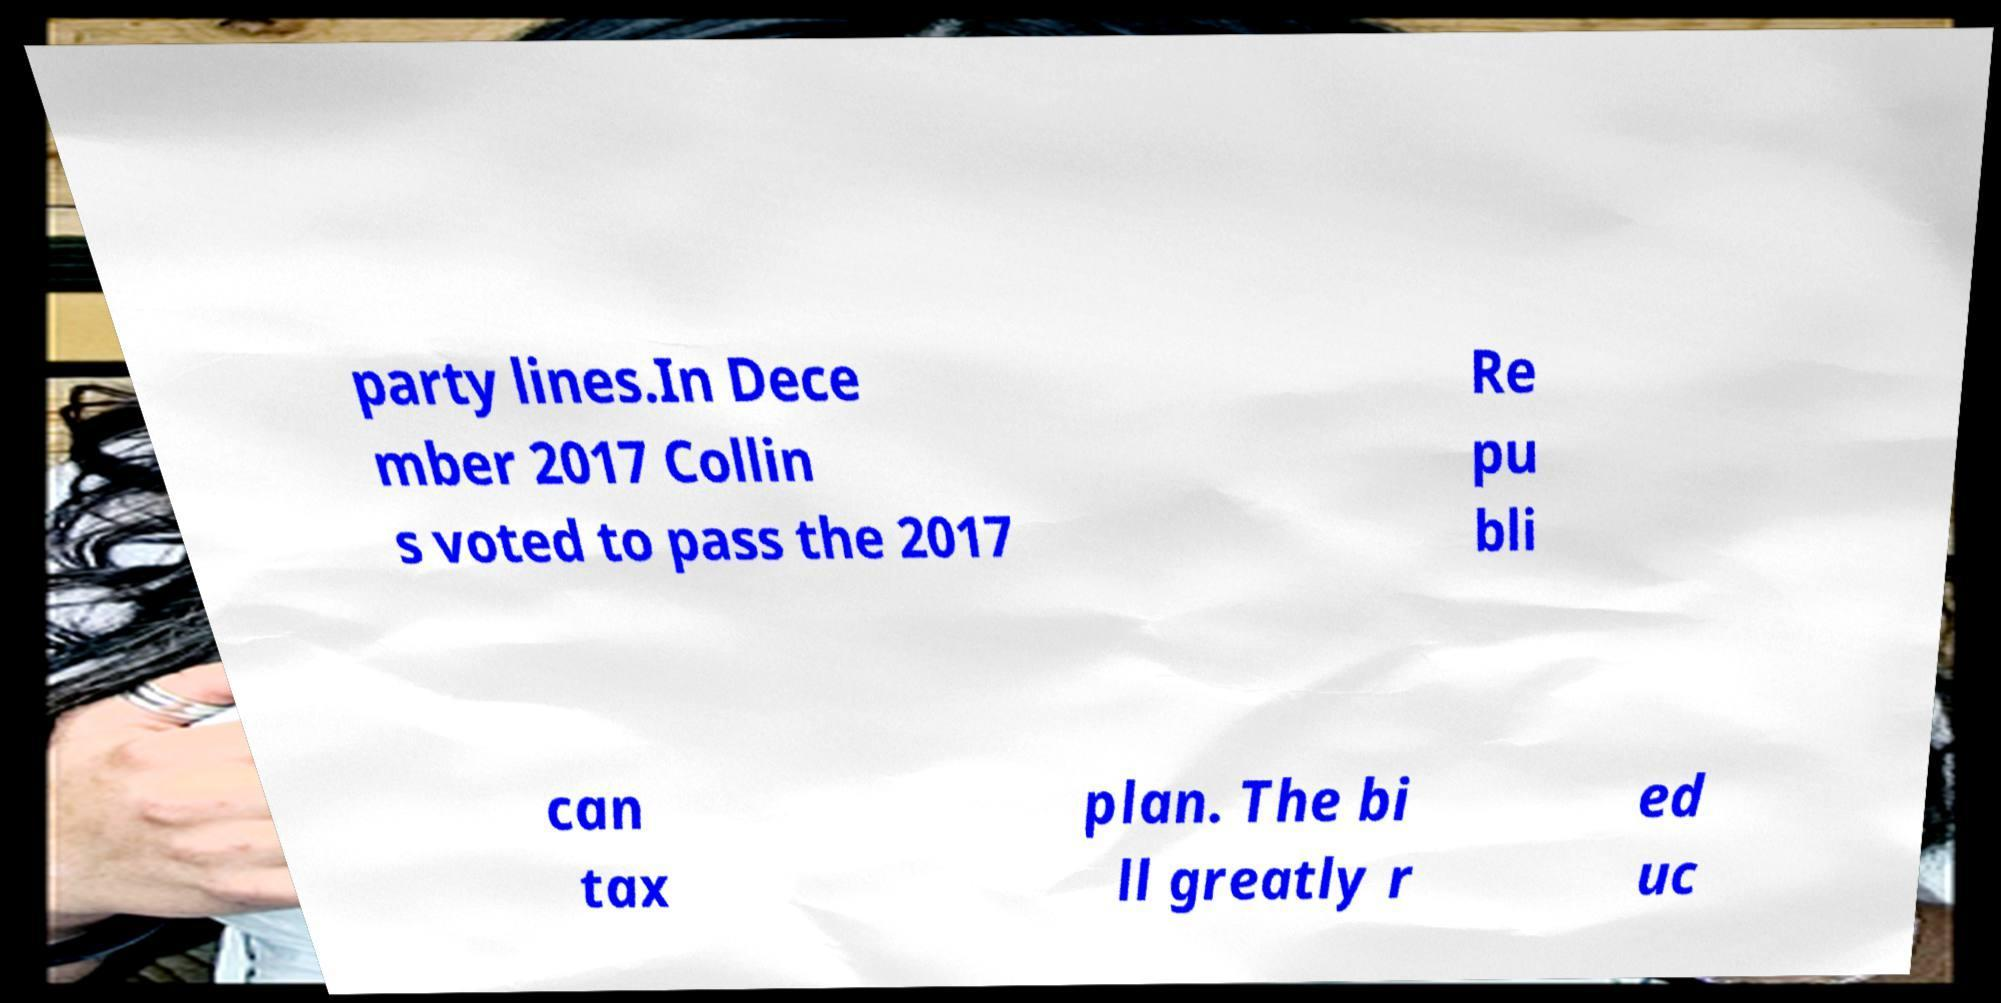Can you accurately transcribe the text from the provided image for me? party lines.In Dece mber 2017 Collin s voted to pass the 2017 Re pu bli can tax plan. The bi ll greatly r ed uc 